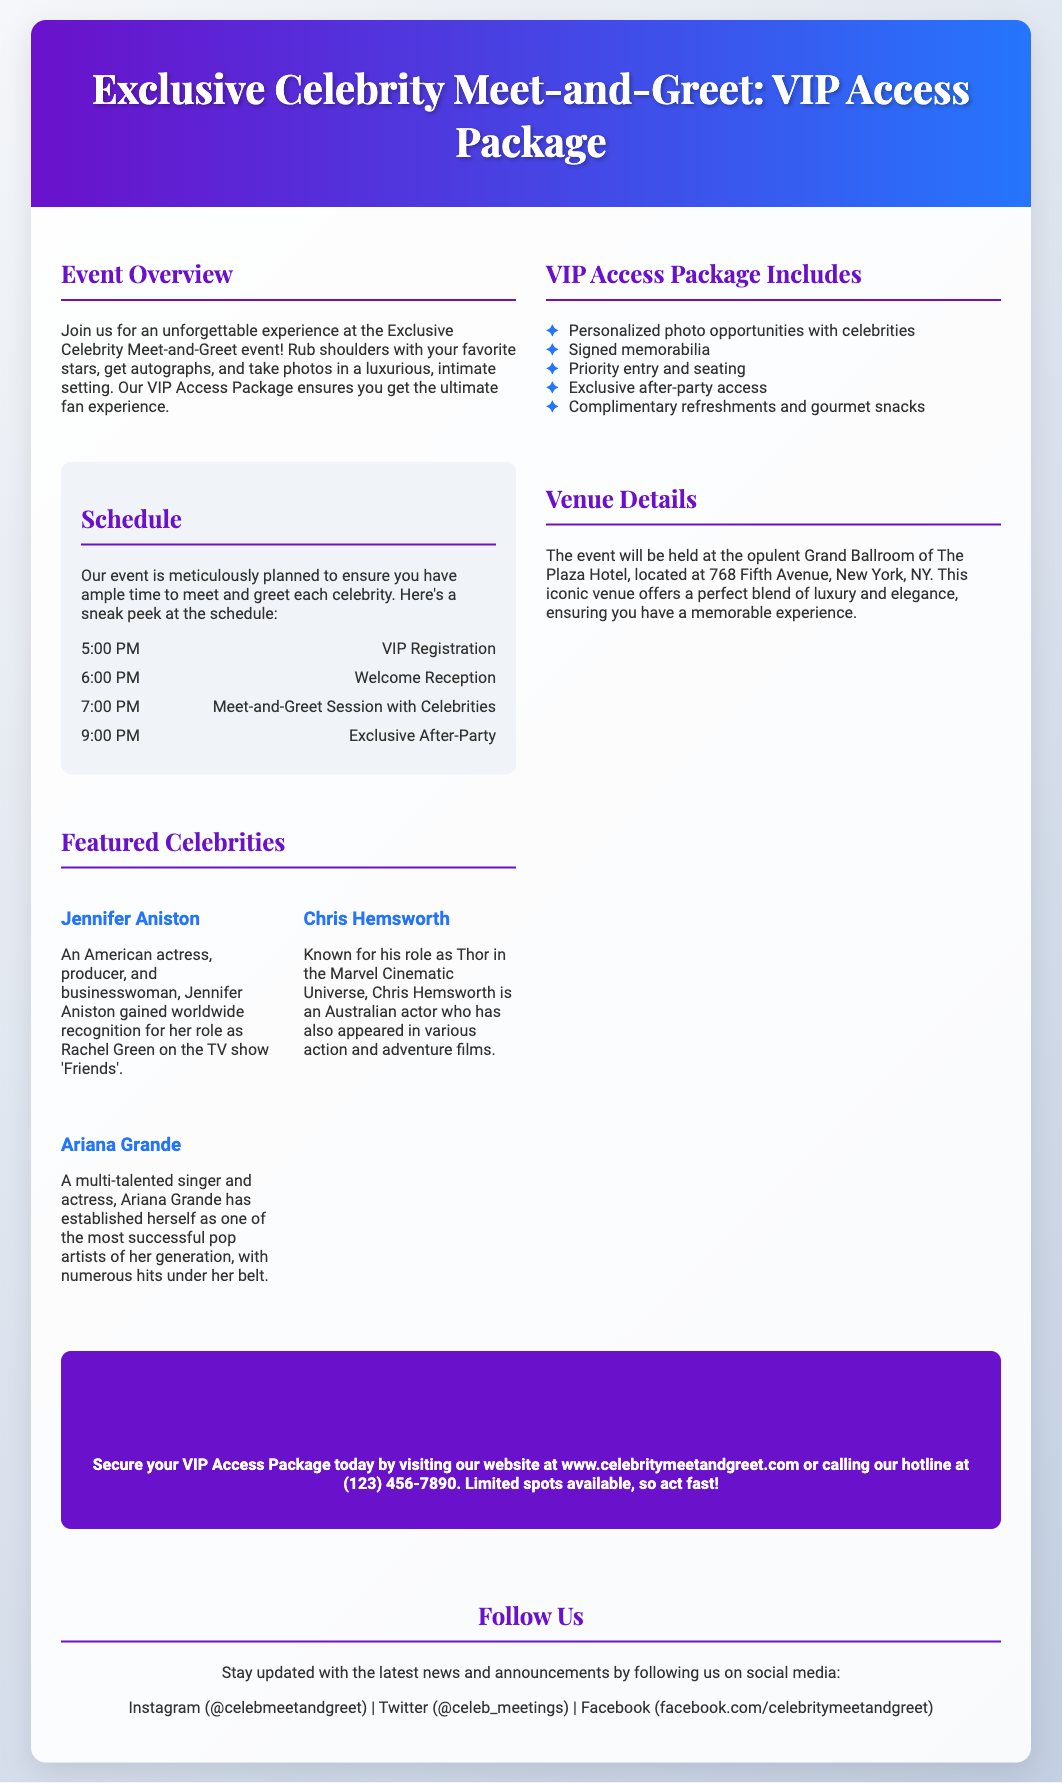What is the name of the event? The name of the event is explicitly mentioned at the top of the document.
Answer: Exclusive Celebrity Meet-and-Greet: VIP Access Package What time does the VIP Registration start? The time for VIP Registration is listed in the schedule section of the document.
Answer: 5:00 PM Where is the event venue located? The location of the event venue is provided in the Venue Details section of the document.
Answer: The Plaza Hotel, 768 Fifth Avenue, New York, NY How many celebrities are featured? The number of celebrities featured can be counted from the Featured Celebrities section.
Answer: 3 What type of refreshments are provided? The type of refreshments is outlined in the VIP Access Package Includes section.
Answer: Complimentary refreshments and gourmet snacks Why should attendees book the VIP Access Package? The advantages of booking the VIP Access Package can be inferred from the list of inclusions.
Answer: Personalized photo opportunities, signed memorabilia, priority entry, and exclusive after-party access What social media platforms can attendees follow? The social media platforms are listed at the bottom of the document in the Follow Us section.
Answer: Instagram, Twitter, Facebook What is the primary purpose of the event? The primary purpose of the event can be found in the Event Overview section of the document.
Answer: Unforgettable experience with celebrities 